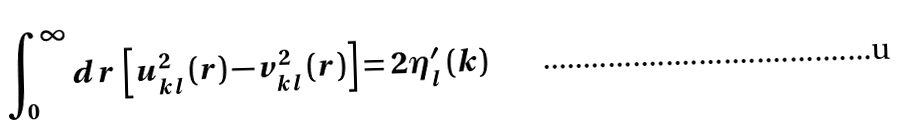Convert formula to latex. <formula><loc_0><loc_0><loc_500><loc_500>\int _ { 0 } ^ { \infty } d r \, \left [ u _ { k l } ^ { 2 } \left ( r \right ) - v _ { k l } ^ { 2 } \left ( r \right ) \right ] = 2 \eta _ { l } ^ { \prime } \left ( k \right )</formula> 